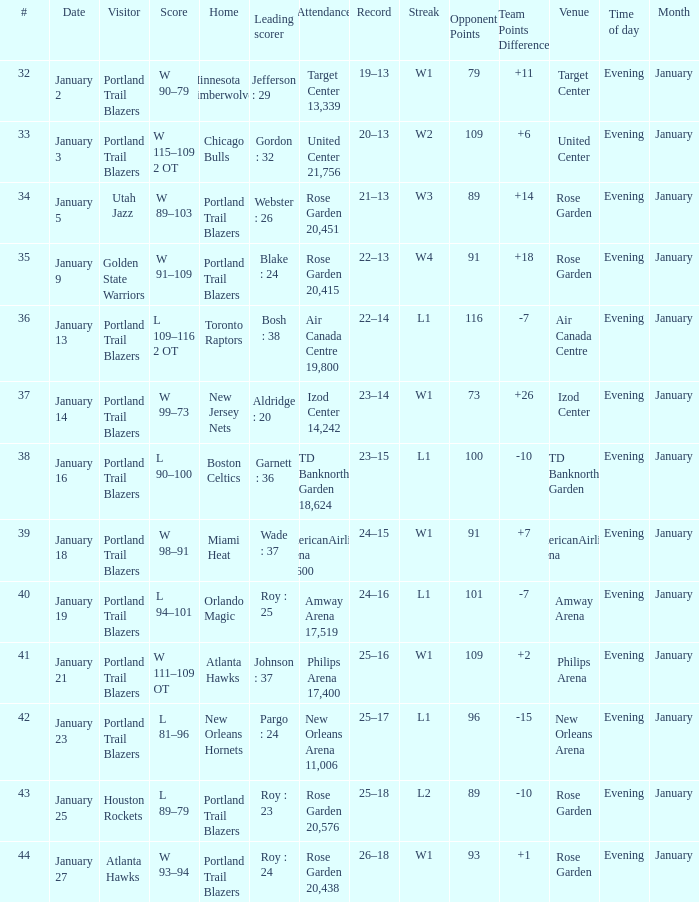What records have a score of l 109–116 2 ot 22–14. 